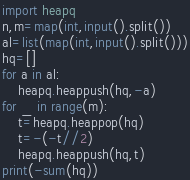Convert code to text. <code><loc_0><loc_0><loc_500><loc_500><_Python_>import heapq
n,m=map(int,input().split())
al=list(map(int,input().split()))
hq=[]
for a in al:
    heapq.heappush(hq,-a)
for _ in range(m):
    t=heapq.heappop(hq)
    t=-(-t//2)
    heapq.heappush(hq,t)
print(-sum(hq))</code> 